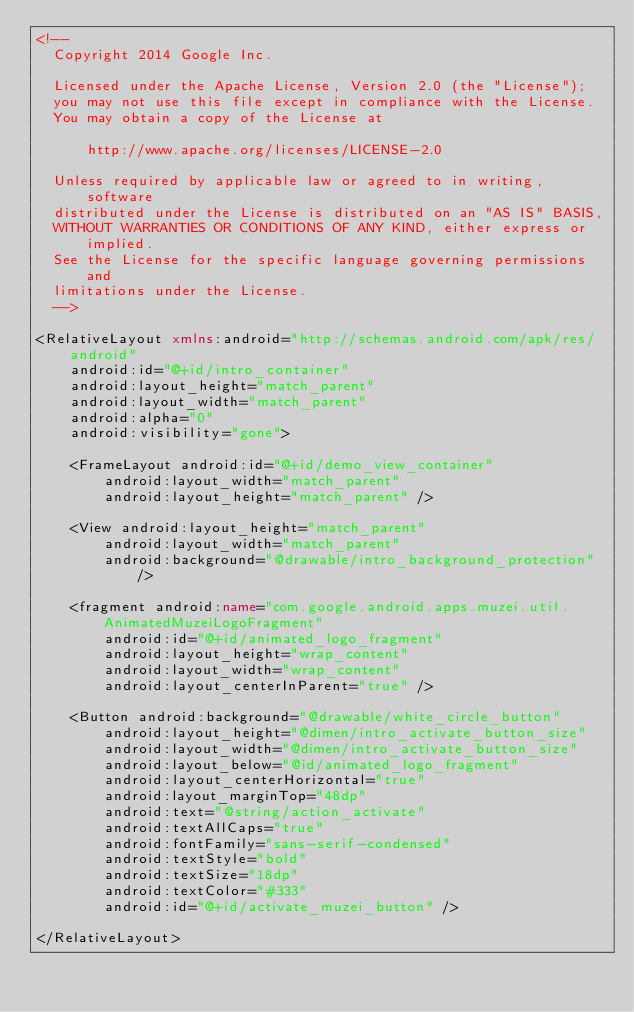<code> <loc_0><loc_0><loc_500><loc_500><_XML_><!--
  Copyright 2014 Google Inc.

  Licensed under the Apache License, Version 2.0 (the "License");
  you may not use this file except in compliance with the License.
  You may obtain a copy of the License at

      http://www.apache.org/licenses/LICENSE-2.0

  Unless required by applicable law or agreed to in writing, software
  distributed under the License is distributed on an "AS IS" BASIS,
  WITHOUT WARRANTIES OR CONDITIONS OF ANY KIND, either express or implied.
  See the License for the specific language governing permissions and
  limitations under the License.
  -->

<RelativeLayout xmlns:android="http://schemas.android.com/apk/res/android"
    android:id="@+id/intro_container"
    android:layout_height="match_parent"
    android:layout_width="match_parent"
    android:alpha="0"
    android:visibility="gone">

    <FrameLayout android:id="@+id/demo_view_container"
        android:layout_width="match_parent"
        android:layout_height="match_parent" />

    <View android:layout_height="match_parent"
        android:layout_width="match_parent"
        android:background="@drawable/intro_background_protection" />

    <fragment android:name="com.google.android.apps.muzei.util.AnimatedMuzeiLogoFragment"
        android:id="@+id/animated_logo_fragment"
        android:layout_height="wrap_content"
        android:layout_width="wrap_content"
        android:layout_centerInParent="true" />

    <Button android:background="@drawable/white_circle_button"
        android:layout_height="@dimen/intro_activate_button_size"
        android:layout_width="@dimen/intro_activate_button_size"
        android:layout_below="@id/animated_logo_fragment"
        android:layout_centerHorizontal="true"
        android:layout_marginTop="48dp"
        android:text="@string/action_activate"
        android:textAllCaps="true"
        android:fontFamily="sans-serif-condensed"
        android:textStyle="bold"
        android:textSize="18dp"
        android:textColor="#333"
        android:id="@+id/activate_muzei_button" />

</RelativeLayout>

</code> 